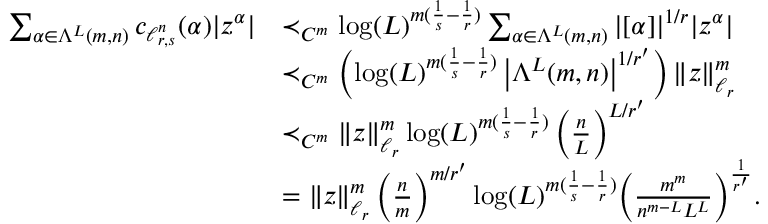Convert formula to latex. <formula><loc_0><loc_0><loc_500><loc_500>\begin{array} { r l } { \sum _ { \alpha \in \Lambda ^ { L } ( m , n ) } c _ { \ell _ { r , s } ^ { n } } ( \alpha ) | z ^ { \alpha } | } & { \prec _ { C ^ { m } } \log ( L ) ^ { m ( \frac { 1 } s } - \frac { 1 } r } ) } \sum _ { \alpha \in \Lambda ^ { L } ( m , n ) } | [ \alpha ] | ^ { 1 / r } | z ^ { \alpha } | } \\ & { \prec _ { C ^ { m } } \left ( \log ( L ) ^ { m ( \frac { 1 } s } - \frac { 1 } r } ) } \left | \Lambda ^ { L } ( m , n ) \right | ^ { 1 / r ^ { \prime } } \right ) \| z \| _ { \ell _ { r } } ^ { m } } \\ & { \prec _ { C ^ { m } } \| z \| _ { \ell _ { r } } ^ { m } \log ( L ) ^ { m ( \frac { 1 } s } - \frac { 1 } r } ) } \left ( \frac { n } { L } \right ) ^ { L / r ^ { \prime } } } \\ & { = \| z \| _ { \ell _ { r } } ^ { m } \, \left ( \frac { n } { m } \right ) ^ { m / r ^ { \prime } } \log ( L ) ^ { m ( \frac { 1 } s } - \frac { 1 } r } ) } \left ( \frac { m ^ { m } } { n ^ { m - L } L ^ { L } } \right ) ^ { \frac { 1 } { r ^ { \prime } } } . } \end{array}</formula> 